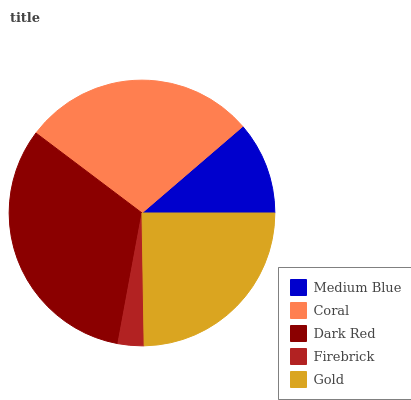Is Firebrick the minimum?
Answer yes or no. Yes. Is Dark Red the maximum?
Answer yes or no. Yes. Is Coral the minimum?
Answer yes or no. No. Is Coral the maximum?
Answer yes or no. No. Is Coral greater than Medium Blue?
Answer yes or no. Yes. Is Medium Blue less than Coral?
Answer yes or no. Yes. Is Medium Blue greater than Coral?
Answer yes or no. No. Is Coral less than Medium Blue?
Answer yes or no. No. Is Gold the high median?
Answer yes or no. Yes. Is Gold the low median?
Answer yes or no. Yes. Is Medium Blue the high median?
Answer yes or no. No. Is Dark Red the low median?
Answer yes or no. No. 